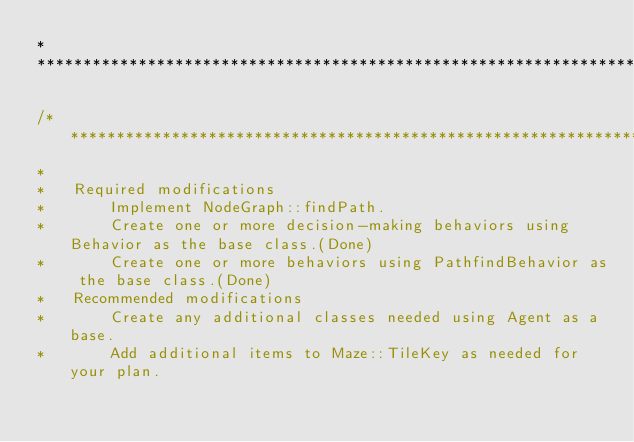<code> <loc_0><loc_0><loc_500><loc_500><_C++_>*
********************************************************************************************/

/*******************************************************************************************
* 
*	Required modifications
*		Implement NodeGraph::findPath.
*		Create one or more decision-making behaviors using Behavior as the base class.(Done)
*		Create one or more behaviors using PathfindBehavior as the base class.(Done)
*	Recommended modifications
*		Create any additional classes needed using Agent as a base.
*		Add additional items to Maze::TileKey as needed for your plan.</code> 